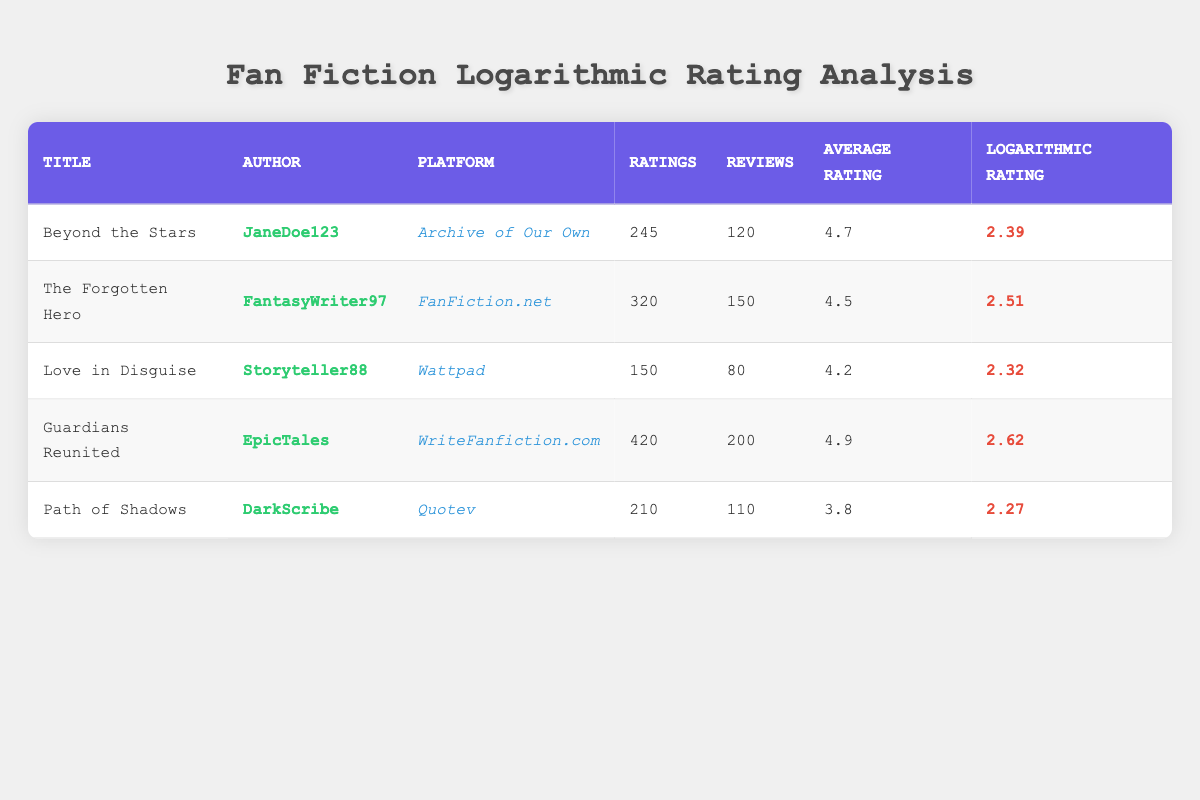What is the average rating of "Guardians Reunited"? The average rating of "Guardians Reunited" is given in the table as 4.9.
Answer: 4.9 How many reviews did "Love in Disguise" receive? The number of reviews for "Love in Disguise" is directly listed in the table as 80.
Answer: 80 Which fan fiction has the highest logarithmic rating? The logarithmic ratings for each entry are compared, and "Guardians Reunited" has the highest value of 2.62.
Answer: Guardians Reunited Is the average rating of "Path of Shadows" greater than 4? The average rating for "Path of Shadows" is 3.8, which is less than 4. Therefore, the statement is false.
Answer: No What is the total number of ratings across all fan fictions? The total ratings can be calculated by summing each entry: 245 + 320 + 150 + 420 + 210 = 1345.
Answer: 1345 How many reviews were submitted for "The Forgotten Hero" and "Guardians Reunited" combined? Adding the reviews for these two titles: 150 (The Forgotten Hero) + 200 (Guardians Reunited) gives a total of 350 reviews.
Answer: 350 What is the difference in logarithmic ratings between "Beyond the Stars" and "Love in Disguise"? The logarithmic ratings are 2.39 (Beyond the Stars) and 2.32 (Love in Disguise). The difference is 2.39 - 2.32 = 0.07.
Answer: 0.07 Which author has the most ratings in total? By comparing the ratings for each work, "EpicTales" (Guardians Reunited) has 420 ratings, which is the highest.
Answer: EpicTales Did "JaneDoe123" receive more reviews than "DarkScribe"? "JaneDoe123" received 120 reviews while "DarkScribe" received 110. Thus, JaneDoe123 received more reviews.
Answer: Yes 